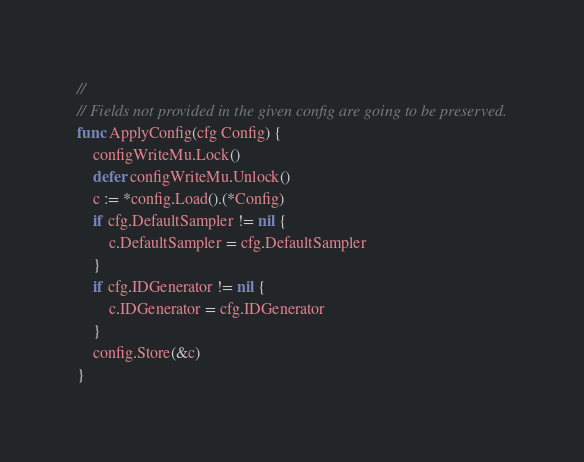Convert code to text. <code><loc_0><loc_0><loc_500><loc_500><_Go_>//
// Fields not provided in the given config are going to be preserved.
func ApplyConfig(cfg Config) {
	configWriteMu.Lock()
	defer configWriteMu.Unlock()
	c := *config.Load().(*Config)
	if cfg.DefaultSampler != nil {
		c.DefaultSampler = cfg.DefaultSampler
	}
	if cfg.IDGenerator != nil {
		c.IDGenerator = cfg.IDGenerator
	}
	config.Store(&c)
}
</code> 